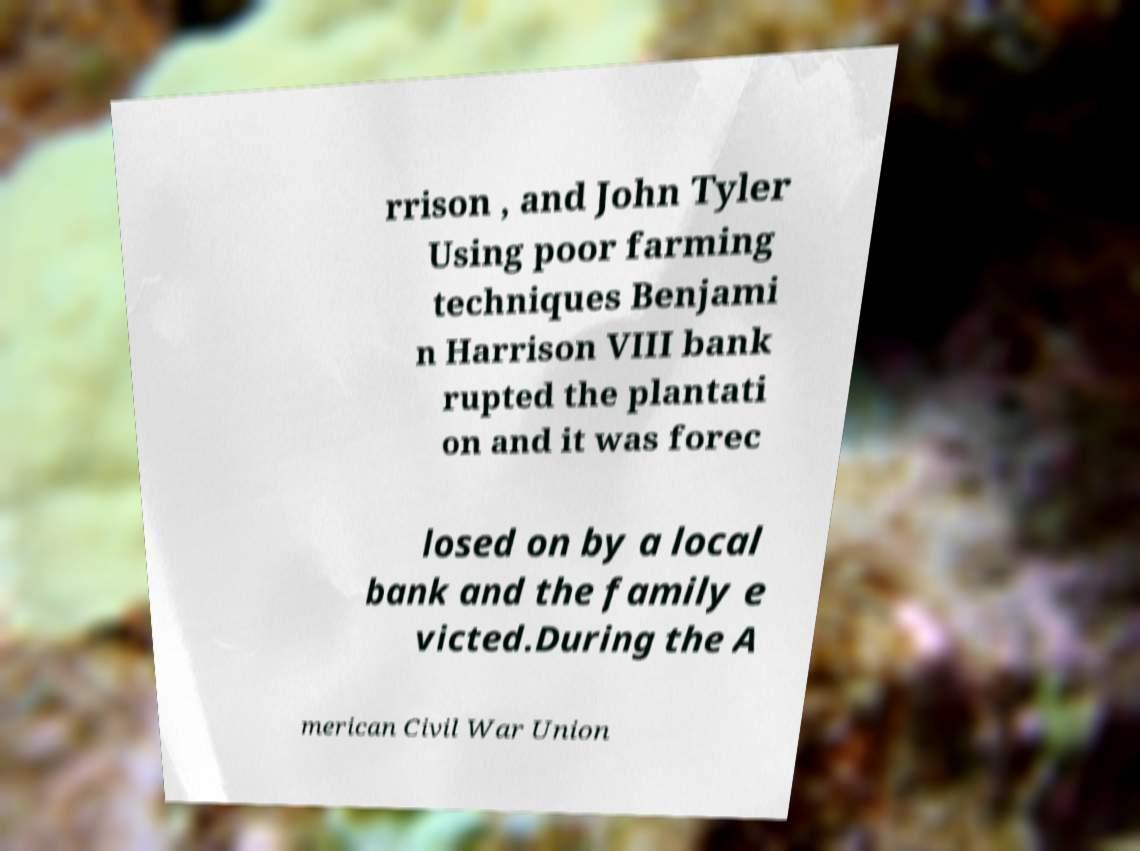Could you assist in decoding the text presented in this image and type it out clearly? rrison , and John Tyler Using poor farming techniques Benjami n Harrison VIII bank rupted the plantati on and it was forec losed on by a local bank and the family e victed.During the A merican Civil War Union 